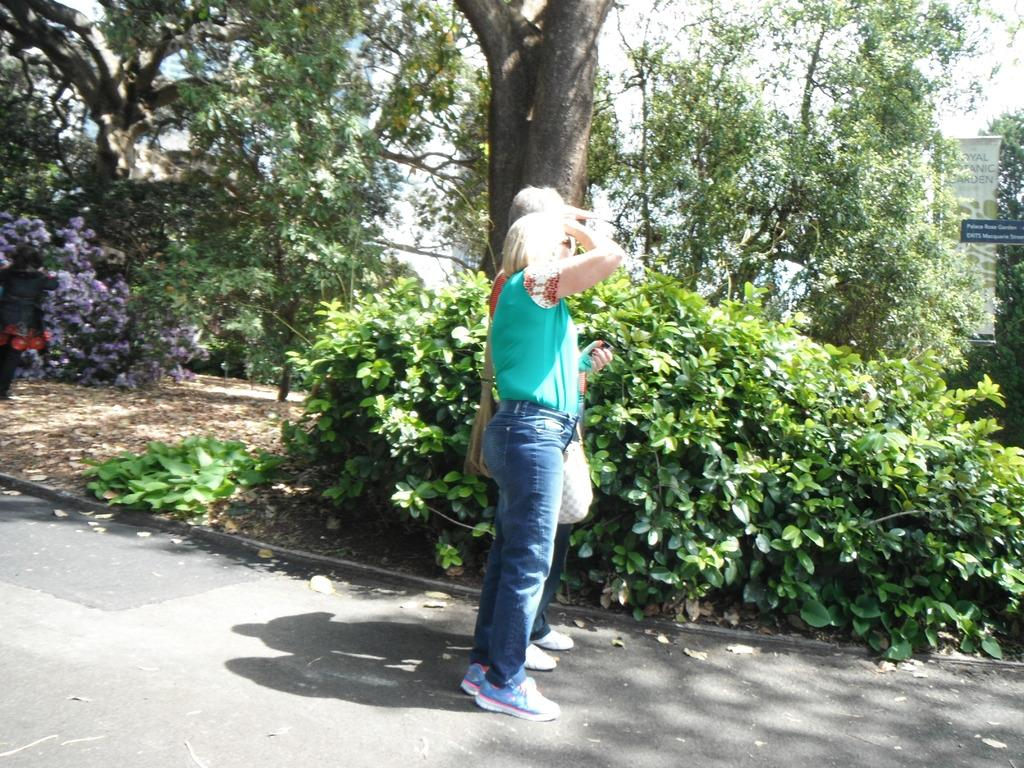How many people are in the image? There are two persons standing on a pathway in the image. What type of natural elements can be seen in the image? There are trees and plants in the image. What is located on the right side of the image? There are boards on the right side of the image. What can be seen in the background of the image? The sky is visible in the background of the image. What time of day is it in the image, and how can you tell? The time of day cannot be determined from the image, as there are no specific details or indicators present. Is there any smoke visible in the image? No, there is no smoke present in the image. 